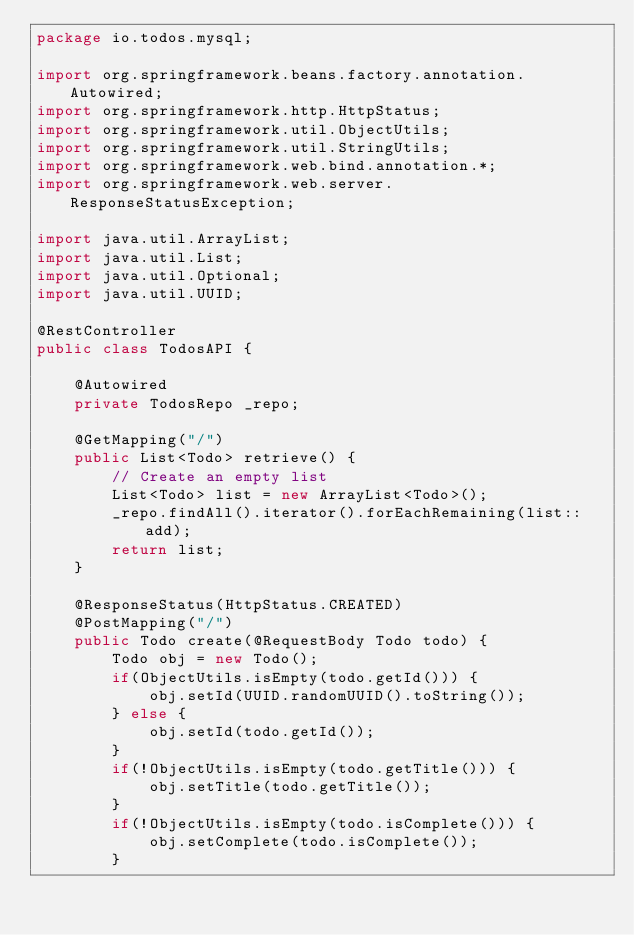<code> <loc_0><loc_0><loc_500><loc_500><_Java_>package io.todos.mysql;

import org.springframework.beans.factory.annotation.Autowired;
import org.springframework.http.HttpStatus;
import org.springframework.util.ObjectUtils;
import org.springframework.util.StringUtils;
import org.springframework.web.bind.annotation.*;
import org.springframework.web.server.ResponseStatusException;

import java.util.ArrayList;
import java.util.List;
import java.util.Optional;
import java.util.UUID;

@RestController
public class TodosAPI {

    @Autowired
    private TodosRepo _repo;

    @GetMapping("/")
    public List<Todo> retrieve() {
        // Create an empty list
        List<Todo> list = new ArrayList<Todo>();
        _repo.findAll().iterator().forEachRemaining(list::add);
        return list;
    }

    @ResponseStatus(HttpStatus.CREATED)
    @PostMapping("/")
    public Todo create(@RequestBody Todo todo) {
        Todo obj = new Todo();
        if(ObjectUtils.isEmpty(todo.getId())) {
            obj.setId(UUID.randomUUID().toString());
        } else {
            obj.setId(todo.getId());
        }
        if(!ObjectUtils.isEmpty(todo.getTitle())) {
            obj.setTitle(todo.getTitle());
        }
        if(!ObjectUtils.isEmpty(todo.isComplete())) {
            obj.setComplete(todo.isComplete());
        }</code> 